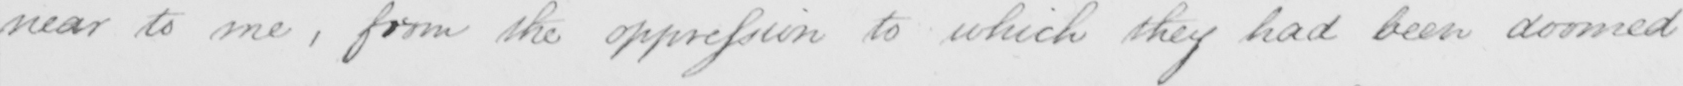What does this handwritten line say? near to me , from the oppression to which they had been doomed 